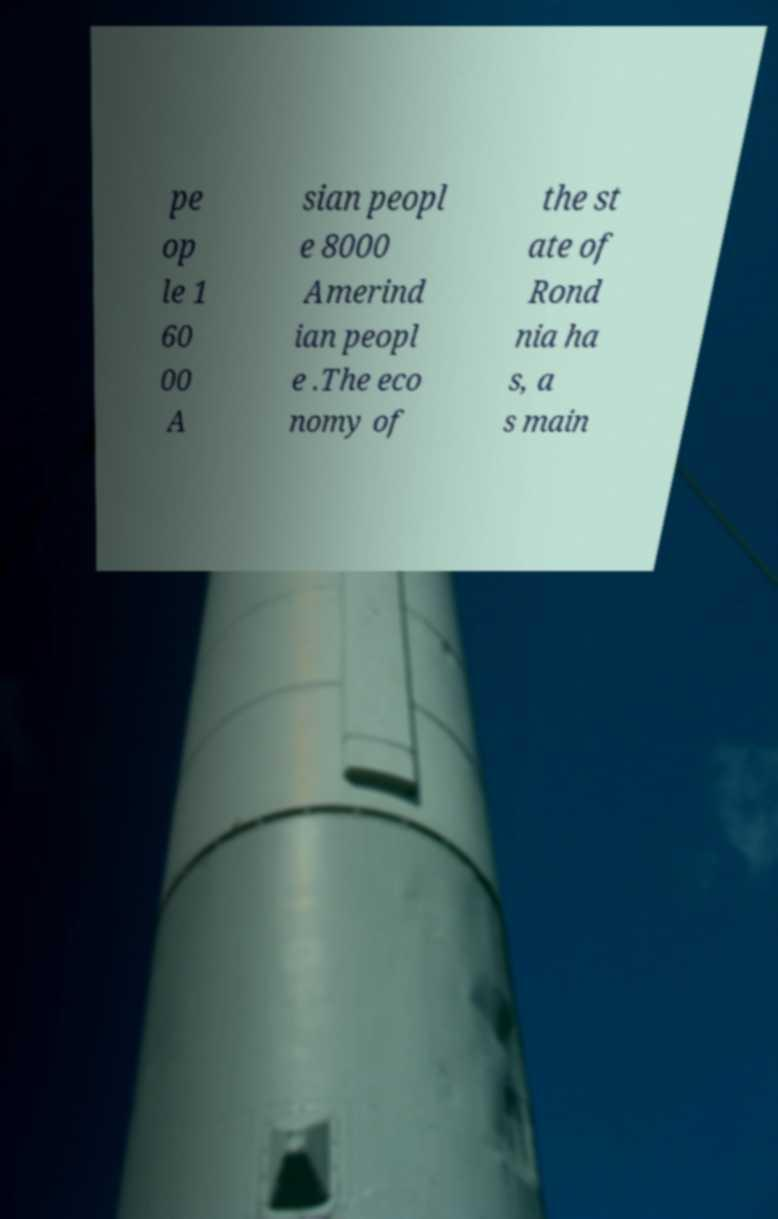Please read and relay the text visible in this image. What does it say? pe op le 1 60 00 A sian peopl e 8000 Amerind ian peopl e .The eco nomy of the st ate of Rond nia ha s, a s main 